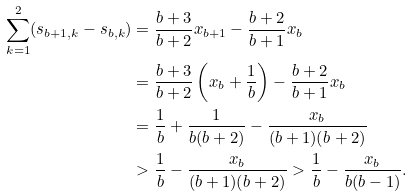Convert formula to latex. <formula><loc_0><loc_0><loc_500><loc_500>\sum _ { k = 1 } ^ { 2 } ( s _ { b + 1 , k } - s _ { b , k } ) & = \frac { b + 3 } { b + 2 } x _ { b + 1 } - \frac { b + 2 } { b + 1 } x _ { b } \\ & = \frac { b + 3 } { b + 2 } \left ( x _ { b } + \frac { 1 } { b } \right ) - \frac { b + 2 } { b + 1 } x _ { b } \\ & = \frac { 1 } { b } + \frac { 1 } { b ( b + 2 ) } - \frac { x _ { b } } { ( b + 1 ) ( b + 2 ) } \\ & > \frac { 1 } { b } - \frac { x _ { b } } { ( b + 1 ) ( b + 2 ) } > \frac { 1 } { b } - \frac { x _ { b } } { b ( b - 1 ) } .</formula> 